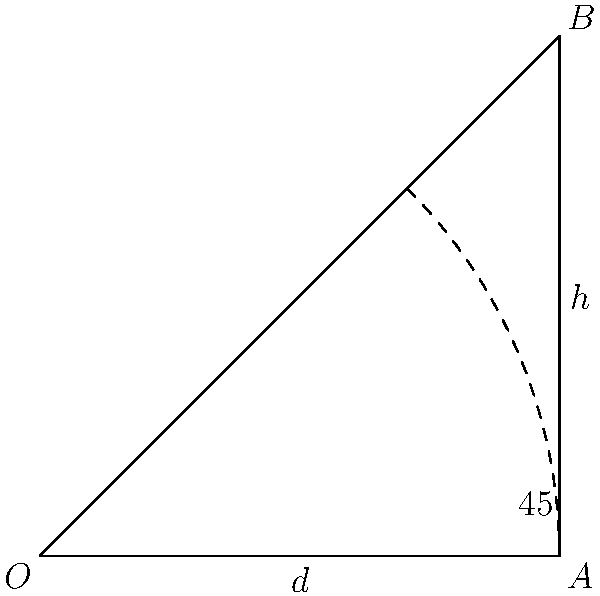As an investor collaborating with a retired professional golfer on a new training device, you're analyzing the optimal angle for a golf club swing. Given that the club head travels in an arc and achieves maximum velocity at impact when the club shaft is perpendicular to the target line, what is the optimal height ($h$) of the club head at impact if the distance from the golfer to the ball ($d$) is 4 feet? Assume the golfer's swing plane creates a 45° angle with the ground. To solve this problem, we'll use trigonometry and the properties of a 45-45-90 triangle:

1) In a 45-45-90 triangle, the two legs are equal, and the hypotenuse is $\sqrt{2}$ times the length of a leg.

2) Let's consider the triangle formed by the golfer (point O), the ball (point A), and the club head at impact (point B).

3) We know that OA = $d$ = 4 feet (the distance from the golfer to the ball).

4) In a 45-45-90 triangle, OA = AB. So, AB is also 4 feet.

5) The height $h$ we're looking for is the same as the length of AB.

Therefore, the optimal height $h$ of the club head at impact is 4 feet.

This solution demonstrates how trigonometry can be applied to optimize golf swing mechanics, which could be valuable for developing training devices or analyzing professional techniques.
Answer: 4 feet 